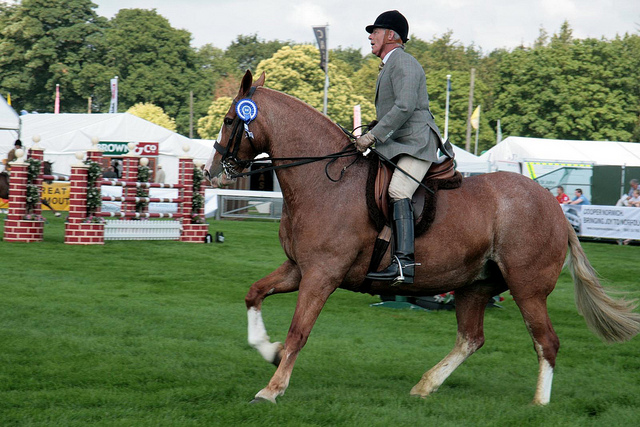Identify the text contained in this image. Co EAT 